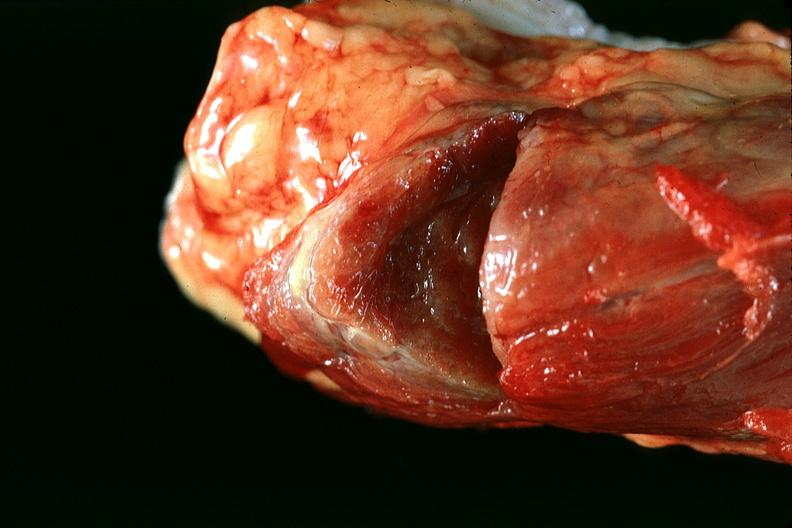s endocrine present?
Answer the question using a single word or phrase. Yes 